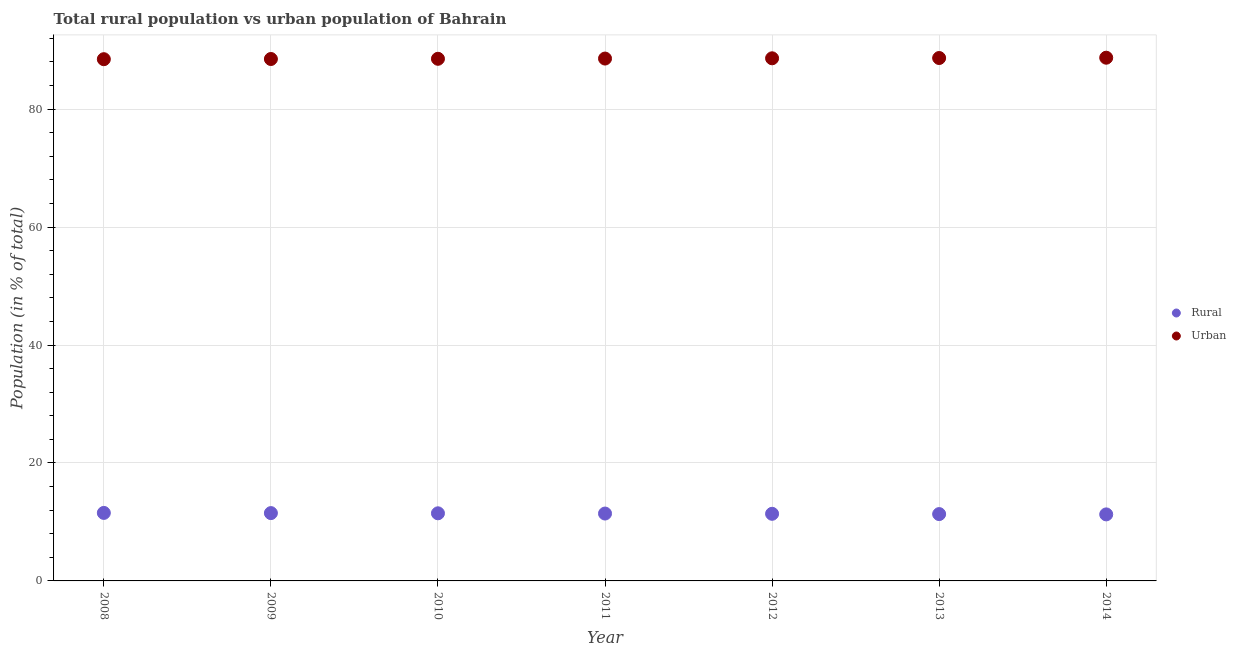How many different coloured dotlines are there?
Give a very brief answer. 2. What is the rural population in 2008?
Provide a succinct answer. 11.53. Across all years, what is the maximum urban population?
Keep it short and to the point. 88.72. Across all years, what is the minimum urban population?
Offer a terse response. 88.47. In which year was the urban population maximum?
Offer a terse response. 2014. In which year was the urban population minimum?
Give a very brief answer. 2008. What is the total rural population in the graph?
Ensure brevity in your answer.  79.92. What is the difference between the urban population in 2011 and that in 2013?
Provide a succinct answer. -0.09. What is the difference between the urban population in 2012 and the rural population in 2008?
Provide a succinct answer. 77.09. What is the average urban population per year?
Offer a very short reply. 88.58. In the year 2014, what is the difference between the rural population and urban population?
Offer a terse response. -77.44. What is the ratio of the urban population in 2010 to that in 2014?
Offer a very short reply. 1. Is the rural population in 2008 less than that in 2010?
Your answer should be very brief. No. Is the difference between the rural population in 2011 and 2013 greater than the difference between the urban population in 2011 and 2013?
Provide a succinct answer. Yes. What is the difference between the highest and the second highest rural population?
Provide a succinct answer. 0.03. What is the difference between the highest and the lowest rural population?
Offer a very short reply. 0.25. Is the rural population strictly less than the urban population over the years?
Offer a terse response. Yes. How many dotlines are there?
Make the answer very short. 2. What is the difference between two consecutive major ticks on the Y-axis?
Give a very brief answer. 20. Are the values on the major ticks of Y-axis written in scientific E-notation?
Your answer should be compact. No. How are the legend labels stacked?
Offer a very short reply. Vertical. What is the title of the graph?
Give a very brief answer. Total rural population vs urban population of Bahrain. Does "Secondary" appear as one of the legend labels in the graph?
Your response must be concise. No. What is the label or title of the X-axis?
Provide a succinct answer. Year. What is the label or title of the Y-axis?
Make the answer very short. Population (in % of total). What is the Population (in % of total) of Rural in 2008?
Your answer should be compact. 11.53. What is the Population (in % of total) of Urban in 2008?
Your response must be concise. 88.47. What is the Population (in % of total) in Rural in 2009?
Offer a terse response. 11.5. What is the Population (in % of total) of Urban in 2009?
Offer a terse response. 88.5. What is the Population (in % of total) of Rural in 2010?
Your answer should be very brief. 11.46. What is the Population (in % of total) in Urban in 2010?
Give a very brief answer. 88.53. What is the Population (in % of total) in Rural in 2011?
Ensure brevity in your answer.  11.43. What is the Population (in % of total) of Urban in 2011?
Offer a terse response. 88.58. What is the Population (in % of total) of Rural in 2012?
Provide a succinct answer. 11.38. What is the Population (in % of total) of Urban in 2012?
Ensure brevity in your answer.  88.62. What is the Population (in % of total) of Rural in 2013?
Offer a terse response. 11.33. What is the Population (in % of total) in Urban in 2013?
Give a very brief answer. 88.67. What is the Population (in % of total) of Rural in 2014?
Your response must be concise. 11.28. What is the Population (in % of total) of Urban in 2014?
Ensure brevity in your answer.  88.72. Across all years, what is the maximum Population (in % of total) in Rural?
Give a very brief answer. 11.53. Across all years, what is the maximum Population (in % of total) in Urban?
Offer a terse response. 88.72. Across all years, what is the minimum Population (in % of total) in Rural?
Your answer should be very brief. 11.28. Across all years, what is the minimum Population (in % of total) in Urban?
Provide a succinct answer. 88.47. What is the total Population (in % of total) in Rural in the graph?
Give a very brief answer. 79.92. What is the total Population (in % of total) in Urban in the graph?
Provide a succinct answer. 620.08. What is the difference between the Population (in % of total) of Rural in 2008 and that in 2009?
Make the answer very short. 0.03. What is the difference between the Population (in % of total) of Urban in 2008 and that in 2009?
Give a very brief answer. -0.03. What is the difference between the Population (in % of total) of Rural in 2008 and that in 2010?
Ensure brevity in your answer.  0.07. What is the difference between the Population (in % of total) of Urban in 2008 and that in 2010?
Provide a succinct answer. -0.07. What is the difference between the Population (in % of total) in Rural in 2008 and that in 2011?
Give a very brief answer. 0.11. What is the difference between the Population (in % of total) in Urban in 2008 and that in 2011?
Offer a very short reply. -0.11. What is the difference between the Population (in % of total) in Rural in 2008 and that in 2012?
Give a very brief answer. 0.15. What is the difference between the Population (in % of total) of Urban in 2008 and that in 2012?
Offer a very short reply. -0.15. What is the difference between the Population (in % of total) of Rural in 2008 and that in 2013?
Offer a terse response. 0.2. What is the difference between the Population (in % of total) of Urban in 2008 and that in 2013?
Your answer should be very brief. -0.2. What is the difference between the Population (in % of total) in Rural in 2008 and that in 2014?
Offer a very short reply. 0.25. What is the difference between the Population (in % of total) in Urban in 2008 and that in 2014?
Provide a short and direct response. -0.25. What is the difference between the Population (in % of total) in Rural in 2009 and that in 2010?
Keep it short and to the point. 0.04. What is the difference between the Population (in % of total) in Urban in 2009 and that in 2010?
Make the answer very short. -0.04. What is the difference between the Population (in % of total) in Rural in 2009 and that in 2011?
Offer a very short reply. 0.07. What is the difference between the Population (in % of total) in Urban in 2009 and that in 2011?
Give a very brief answer. -0.07. What is the difference between the Population (in % of total) of Rural in 2009 and that in 2012?
Your response must be concise. 0.12. What is the difference between the Population (in % of total) of Urban in 2009 and that in 2012?
Give a very brief answer. -0.12. What is the difference between the Population (in % of total) in Rural in 2009 and that in 2013?
Provide a short and direct response. 0.17. What is the difference between the Population (in % of total) in Urban in 2009 and that in 2013?
Give a very brief answer. -0.17. What is the difference between the Population (in % of total) of Rural in 2009 and that in 2014?
Give a very brief answer. 0.22. What is the difference between the Population (in % of total) of Urban in 2009 and that in 2014?
Provide a succinct answer. -0.22. What is the difference between the Population (in % of total) in Rural in 2010 and that in 2011?
Ensure brevity in your answer.  0.04. What is the difference between the Population (in % of total) of Urban in 2010 and that in 2011?
Your answer should be compact. -0.04. What is the difference between the Population (in % of total) of Rural in 2010 and that in 2012?
Offer a very short reply. 0.08. What is the difference between the Population (in % of total) in Urban in 2010 and that in 2012?
Offer a terse response. -0.08. What is the difference between the Population (in % of total) in Rural in 2010 and that in 2013?
Offer a terse response. 0.13. What is the difference between the Population (in % of total) of Urban in 2010 and that in 2013?
Give a very brief answer. -0.13. What is the difference between the Population (in % of total) of Rural in 2010 and that in 2014?
Your answer should be very brief. 0.18. What is the difference between the Population (in % of total) of Urban in 2010 and that in 2014?
Offer a very short reply. -0.18. What is the difference between the Population (in % of total) in Rural in 2011 and that in 2012?
Your answer should be compact. 0.04. What is the difference between the Population (in % of total) in Urban in 2011 and that in 2012?
Provide a short and direct response. -0.04. What is the difference between the Population (in % of total) of Rural in 2011 and that in 2013?
Keep it short and to the point. 0.09. What is the difference between the Population (in % of total) in Urban in 2011 and that in 2013?
Offer a terse response. -0.09. What is the difference between the Population (in % of total) in Rural in 2011 and that in 2014?
Your response must be concise. 0.14. What is the difference between the Population (in % of total) in Urban in 2011 and that in 2014?
Keep it short and to the point. -0.14. What is the difference between the Population (in % of total) in Rural in 2012 and that in 2013?
Your response must be concise. 0.05. What is the difference between the Population (in % of total) in Urban in 2012 and that in 2013?
Provide a short and direct response. -0.05. What is the difference between the Population (in % of total) of Rural in 2013 and that in 2014?
Provide a succinct answer. 0.05. What is the difference between the Population (in % of total) of Urban in 2013 and that in 2014?
Provide a short and direct response. -0.05. What is the difference between the Population (in % of total) in Rural in 2008 and the Population (in % of total) in Urban in 2009?
Provide a short and direct response. -76.97. What is the difference between the Population (in % of total) of Rural in 2008 and the Population (in % of total) of Urban in 2010?
Your answer should be very brief. -77. What is the difference between the Population (in % of total) in Rural in 2008 and the Population (in % of total) in Urban in 2011?
Make the answer very short. -77.04. What is the difference between the Population (in % of total) in Rural in 2008 and the Population (in % of total) in Urban in 2012?
Keep it short and to the point. -77.09. What is the difference between the Population (in % of total) in Rural in 2008 and the Population (in % of total) in Urban in 2013?
Your answer should be very brief. -77.14. What is the difference between the Population (in % of total) of Rural in 2008 and the Population (in % of total) of Urban in 2014?
Provide a succinct answer. -77.19. What is the difference between the Population (in % of total) of Rural in 2009 and the Population (in % of total) of Urban in 2010?
Your answer should be compact. -77.03. What is the difference between the Population (in % of total) of Rural in 2009 and the Population (in % of total) of Urban in 2011?
Provide a short and direct response. -77.08. What is the difference between the Population (in % of total) of Rural in 2009 and the Population (in % of total) of Urban in 2012?
Make the answer very short. -77.12. What is the difference between the Population (in % of total) in Rural in 2009 and the Population (in % of total) in Urban in 2013?
Provide a succinct answer. -77.17. What is the difference between the Population (in % of total) in Rural in 2009 and the Population (in % of total) in Urban in 2014?
Provide a succinct answer. -77.22. What is the difference between the Population (in % of total) of Rural in 2010 and the Population (in % of total) of Urban in 2011?
Provide a short and direct response. -77.11. What is the difference between the Population (in % of total) of Rural in 2010 and the Population (in % of total) of Urban in 2012?
Offer a terse response. -77.15. What is the difference between the Population (in % of total) in Rural in 2010 and the Population (in % of total) in Urban in 2013?
Offer a terse response. -77.2. What is the difference between the Population (in % of total) in Rural in 2010 and the Population (in % of total) in Urban in 2014?
Your answer should be compact. -77.25. What is the difference between the Population (in % of total) in Rural in 2011 and the Population (in % of total) in Urban in 2012?
Offer a very short reply. -77.19. What is the difference between the Population (in % of total) in Rural in 2011 and the Population (in % of total) in Urban in 2013?
Offer a very short reply. -77.24. What is the difference between the Population (in % of total) in Rural in 2011 and the Population (in % of total) in Urban in 2014?
Give a very brief answer. -77.29. What is the difference between the Population (in % of total) in Rural in 2012 and the Population (in % of total) in Urban in 2013?
Offer a terse response. -77.29. What is the difference between the Population (in % of total) of Rural in 2012 and the Population (in % of total) of Urban in 2014?
Make the answer very short. -77.34. What is the difference between the Population (in % of total) in Rural in 2013 and the Population (in % of total) in Urban in 2014?
Ensure brevity in your answer.  -77.39. What is the average Population (in % of total) of Rural per year?
Your answer should be very brief. 11.42. What is the average Population (in % of total) in Urban per year?
Make the answer very short. 88.58. In the year 2008, what is the difference between the Population (in % of total) of Rural and Population (in % of total) of Urban?
Keep it short and to the point. -76.94. In the year 2009, what is the difference between the Population (in % of total) of Rural and Population (in % of total) of Urban?
Provide a short and direct response. -77. In the year 2010, what is the difference between the Population (in % of total) in Rural and Population (in % of total) in Urban?
Provide a succinct answer. -77.07. In the year 2011, what is the difference between the Population (in % of total) of Rural and Population (in % of total) of Urban?
Offer a very short reply. -77.15. In the year 2012, what is the difference between the Population (in % of total) in Rural and Population (in % of total) in Urban?
Provide a succinct answer. -77.24. In the year 2013, what is the difference between the Population (in % of total) of Rural and Population (in % of total) of Urban?
Ensure brevity in your answer.  -77.33. In the year 2014, what is the difference between the Population (in % of total) of Rural and Population (in % of total) of Urban?
Offer a terse response. -77.44. What is the ratio of the Population (in % of total) in Rural in 2008 to that in 2009?
Keep it short and to the point. 1. What is the ratio of the Population (in % of total) in Rural in 2008 to that in 2010?
Provide a succinct answer. 1.01. What is the ratio of the Population (in % of total) of Rural in 2008 to that in 2011?
Offer a very short reply. 1.01. What is the ratio of the Population (in % of total) of Rural in 2008 to that in 2012?
Ensure brevity in your answer.  1.01. What is the ratio of the Population (in % of total) of Urban in 2008 to that in 2012?
Give a very brief answer. 1. What is the ratio of the Population (in % of total) of Rural in 2008 to that in 2013?
Give a very brief answer. 1.02. What is the ratio of the Population (in % of total) of Urban in 2008 to that in 2013?
Make the answer very short. 1. What is the ratio of the Population (in % of total) of Rural in 2008 to that in 2014?
Your response must be concise. 1.02. What is the ratio of the Population (in % of total) of Urban in 2009 to that in 2010?
Make the answer very short. 1. What is the ratio of the Population (in % of total) of Rural in 2009 to that in 2011?
Your response must be concise. 1.01. What is the ratio of the Population (in % of total) of Rural in 2009 to that in 2012?
Your response must be concise. 1.01. What is the ratio of the Population (in % of total) of Rural in 2009 to that in 2013?
Ensure brevity in your answer.  1.01. What is the ratio of the Population (in % of total) of Urban in 2009 to that in 2013?
Provide a short and direct response. 1. What is the ratio of the Population (in % of total) of Rural in 2009 to that in 2014?
Give a very brief answer. 1.02. What is the ratio of the Population (in % of total) in Urban in 2010 to that in 2011?
Offer a terse response. 1. What is the ratio of the Population (in % of total) of Rural in 2010 to that in 2012?
Your response must be concise. 1.01. What is the ratio of the Population (in % of total) of Urban in 2010 to that in 2012?
Your answer should be compact. 1. What is the ratio of the Population (in % of total) of Rural in 2010 to that in 2013?
Your answer should be very brief. 1.01. What is the ratio of the Population (in % of total) of Rural in 2010 to that in 2014?
Give a very brief answer. 1.02. What is the ratio of the Population (in % of total) in Urban in 2011 to that in 2012?
Ensure brevity in your answer.  1. What is the ratio of the Population (in % of total) in Rural in 2011 to that in 2014?
Make the answer very short. 1.01. What is the ratio of the Population (in % of total) in Urban in 2012 to that in 2013?
Ensure brevity in your answer.  1. What is the ratio of the Population (in % of total) of Rural in 2012 to that in 2014?
Make the answer very short. 1.01. What is the ratio of the Population (in % of total) of Urban in 2012 to that in 2014?
Ensure brevity in your answer.  1. What is the difference between the highest and the second highest Population (in % of total) of Rural?
Offer a terse response. 0.03. What is the difference between the highest and the second highest Population (in % of total) of Urban?
Provide a short and direct response. 0.05. What is the difference between the highest and the lowest Population (in % of total) in Rural?
Offer a very short reply. 0.25. What is the difference between the highest and the lowest Population (in % of total) of Urban?
Your answer should be compact. 0.25. 